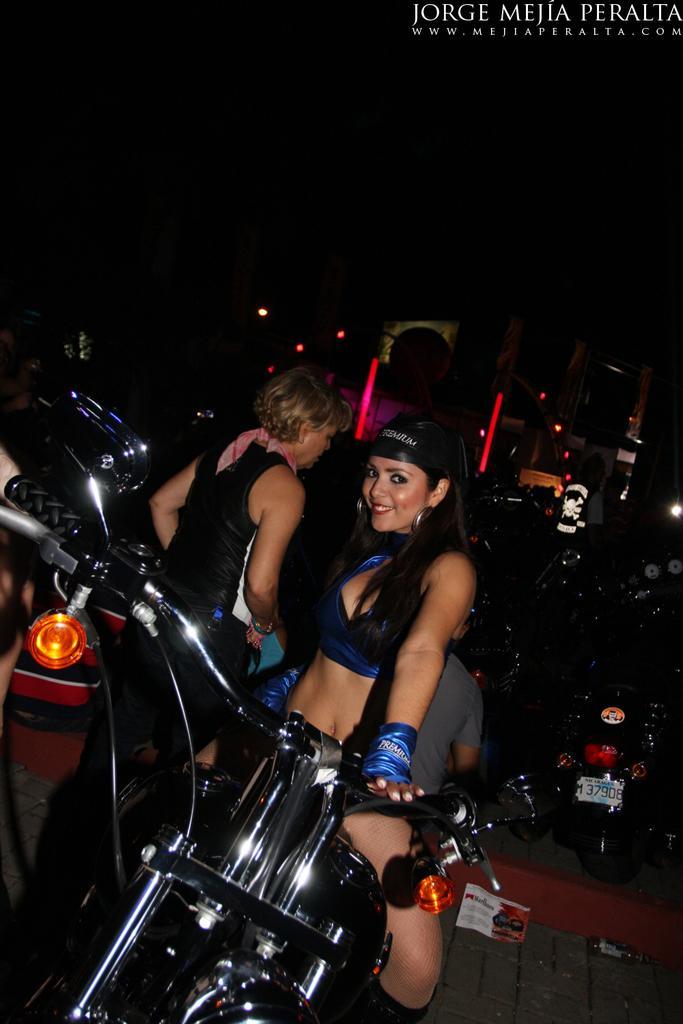Can you describe this image briefly? In this image, There is a bike which is in black color and there is a woman sitting on the bike, In the background there are some people standing and there are some bikes in the background. 